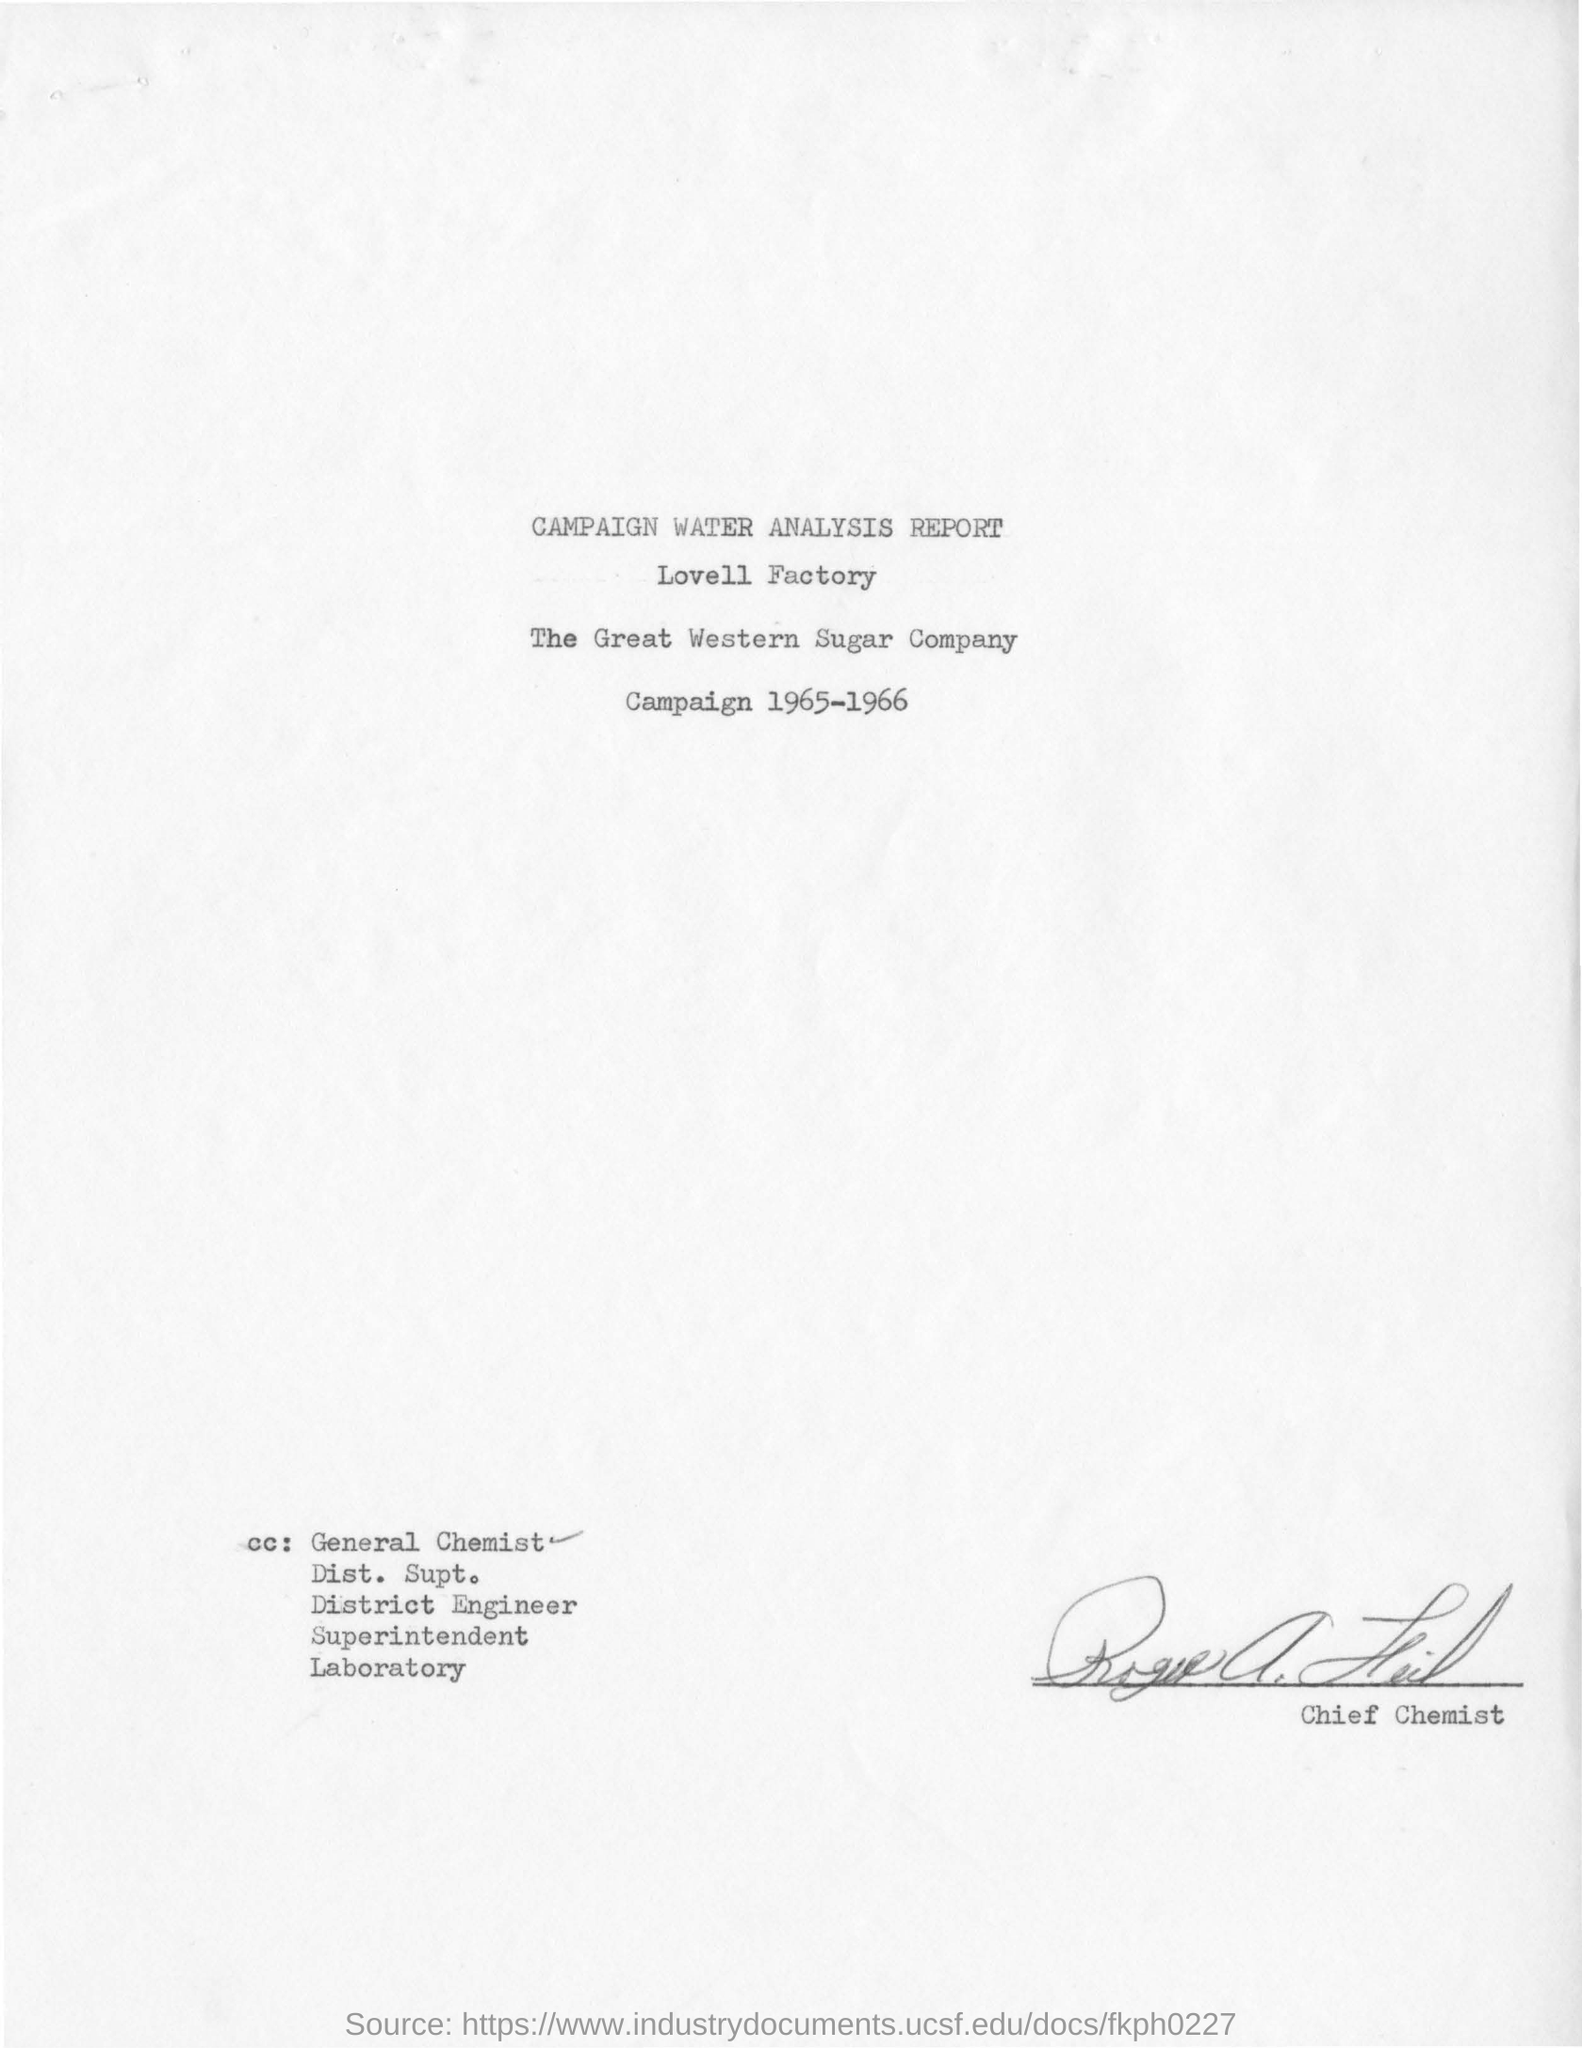Outline some significant characteristics in this image. The Lovell Factory is the name of a factory. The year mentioned at the top of the document is 1965-1966. 